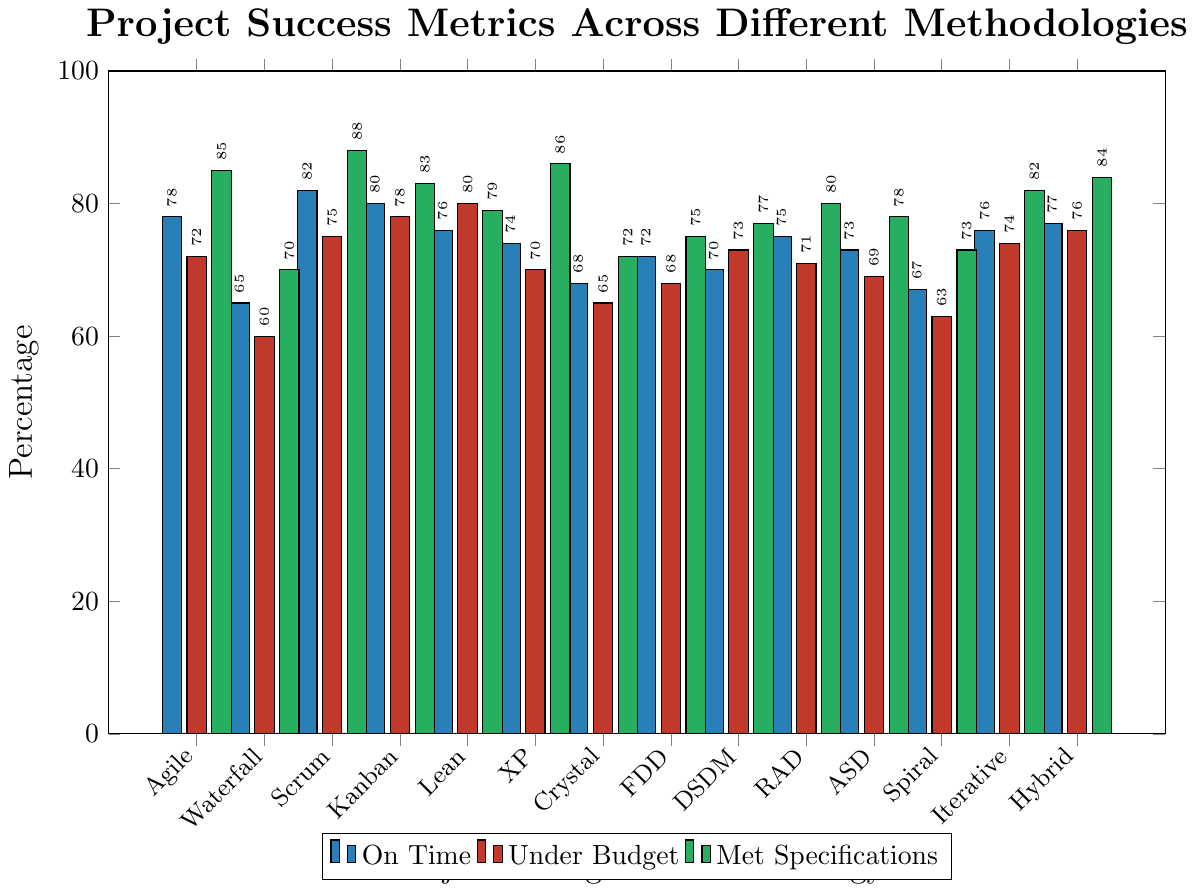Which methodology shows the highest percentage of projects completed on time? By visually inspecting the heights of the "On Time" bars, we see that Scrum has the highest bar among all methodologies in this category, indicating it has the highest percentage of projects completed on time.
Answer: Scrum What is the difference between the proportion of projects completed under budget for Agile and Waterfall methodologies? The percentage of projects completed under budget for Agile is 72%, and for Waterfall, it is 60%. The difference between these two percentages is 72% - 60% = 12%.
Answer: 12% Which methodology has the lowest percentage of projects meeting all specifications? By visually inspecting the heights of the "Met Specifications" bars, we see that Waterfall has the lowest bar, indicating it has the lowest percentage of projects meeting all specifications.
Answer: Waterfall Compare the average percentages for projects completed on time between Agile, Scrum, and Kanban methodologies. Which one has the highest average? The percentages for being on time are 78% for Agile, 82% for Scrum, and 80% for Kanban. The average for Agile is 78, for Scrum is 82, and for Kanban is 80. Thus, Scrum has the highest average percentage for being on time.
Answer: Scrum For which metric does Kanban show the highest performance compared to Agile? Kanban outperforms Agile in two metrics: "Under Budget" (78% vs. 72%) and "On Time" (80% vs. 78%) but falls short in "Met Specifications" (83% vs. 85%). Thus, Kanban shows the highest performance in the "Under Budget" metric.
Answer: Under Budget What is the sum of percentages for the "On Time" metric for the methodologies: Agile, Waterfall, and Scrum? The percentages for the "On Time" metric are 78% for Agile, 65% for Waterfall, and 82% for Scrum. The sum is 78 + 65 + 82 = 225.
Answer: 225 Which methodology has a higher percentage of projects under budget: Lean or Hybrid? By visually inspecting the "Under Budget" bars, we see that Lean (80%) has slightly higher performance than Hybrid (76%).
Answer: Lean If you average the percentages for Agile in all three metrics, what value do you get? The percentages for Agile are 78% (On Time), 72% (Under Budget), and 85% (Met Specifications). The average is calculated as (78 + 72 + 85) / 3 = 235 / 3 ≈ 78.33.
Answer: 78.33 Which methodology has equal or closest values for the percentage of projects completed under budget and met specifications? By comparing the "Under Budget" and "Met Specifications" bars, Spiral has the closest values: 63% under budget and 73% met specifications, a difference of 10%, which is the smallest among all methodologies.
Answer: Spiral Comparing the proportion of projects that met specifications, which methodology performs better: XP or Lean? By visually inspecting the "Met Specifications" bars, XP has 86% and Lean has 79%, so XP performs better.
Answer: XP 